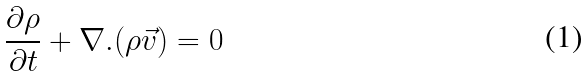Convert formula to latex. <formula><loc_0><loc_0><loc_500><loc_500>\frac { { \partial } { \rho } } { { \partial } t } + { \nabla } . ( { \rho } \vec { v } ) = 0</formula> 